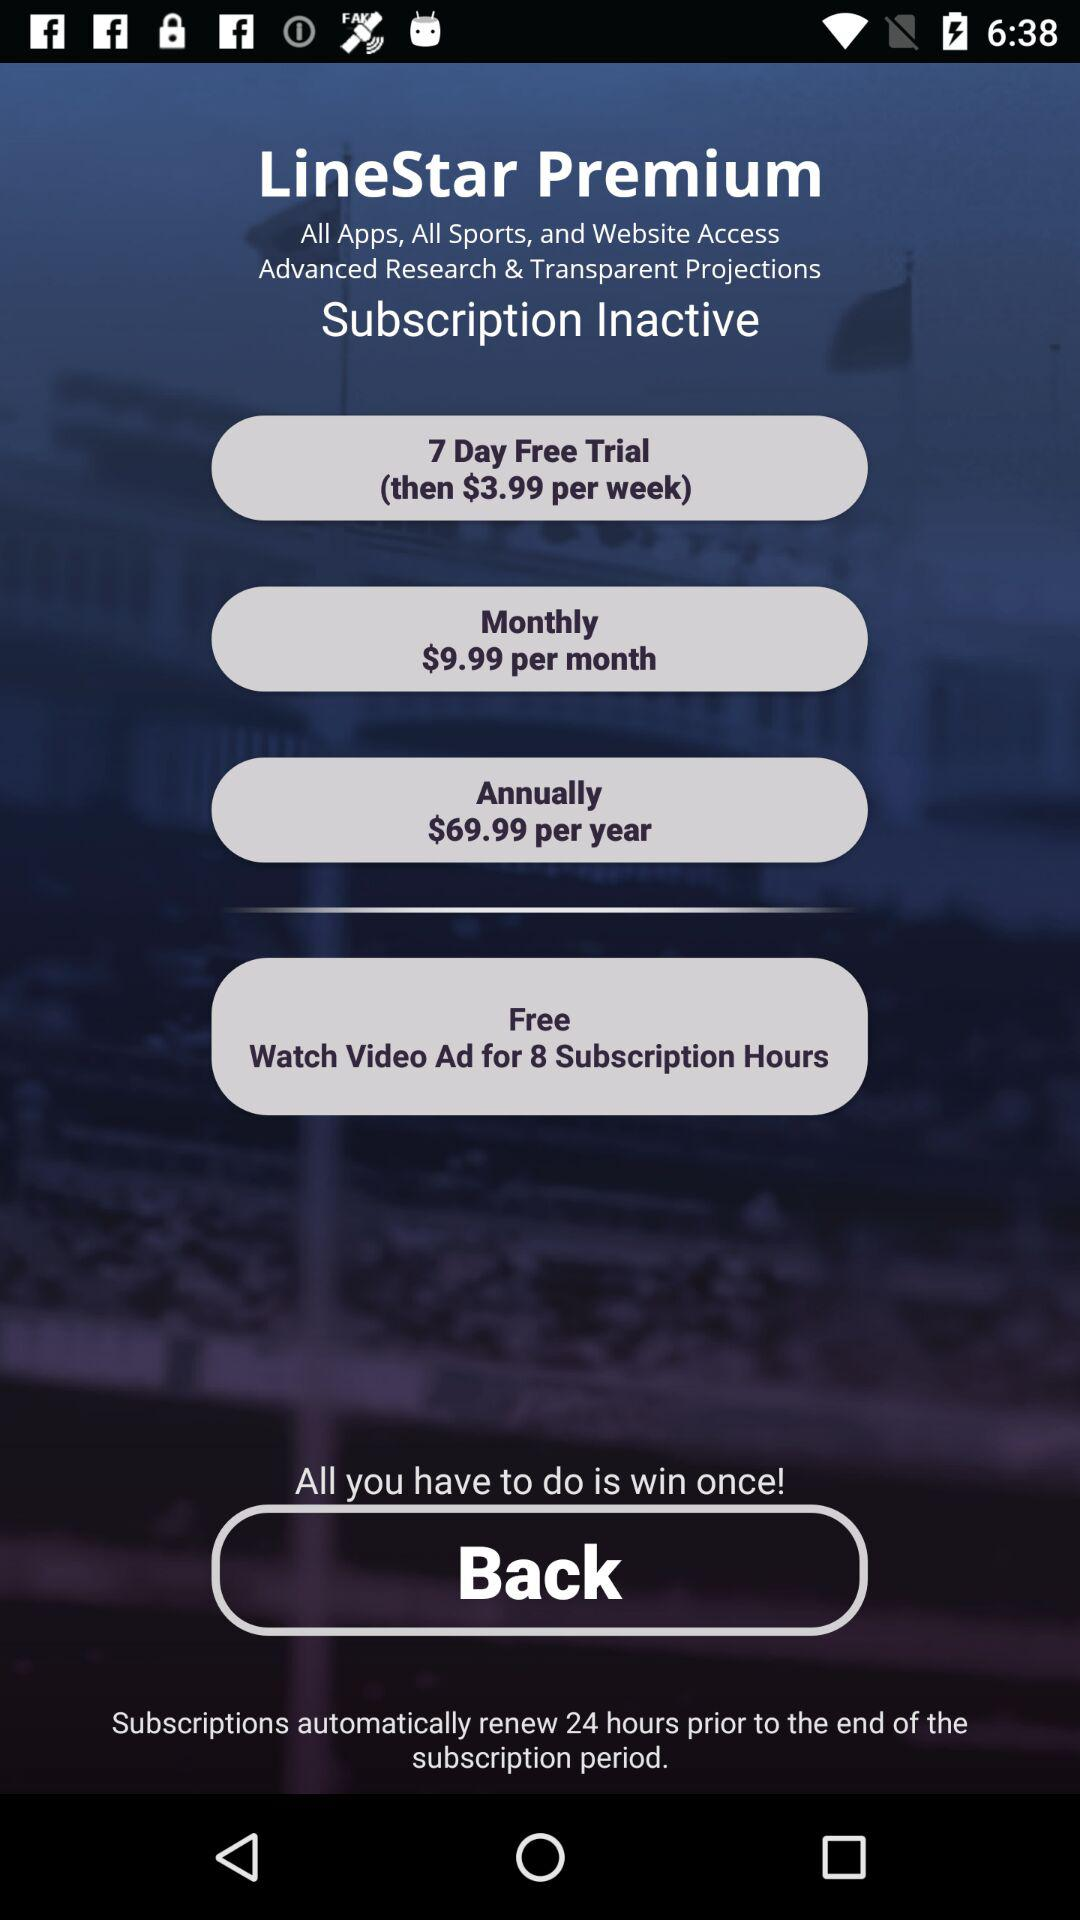Prior to how many hours is the subscription renewed? The subscription is renewed 24 hours prior to the end of the subscription period. 